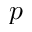Convert formula to latex. <formula><loc_0><loc_0><loc_500><loc_500>p</formula> 